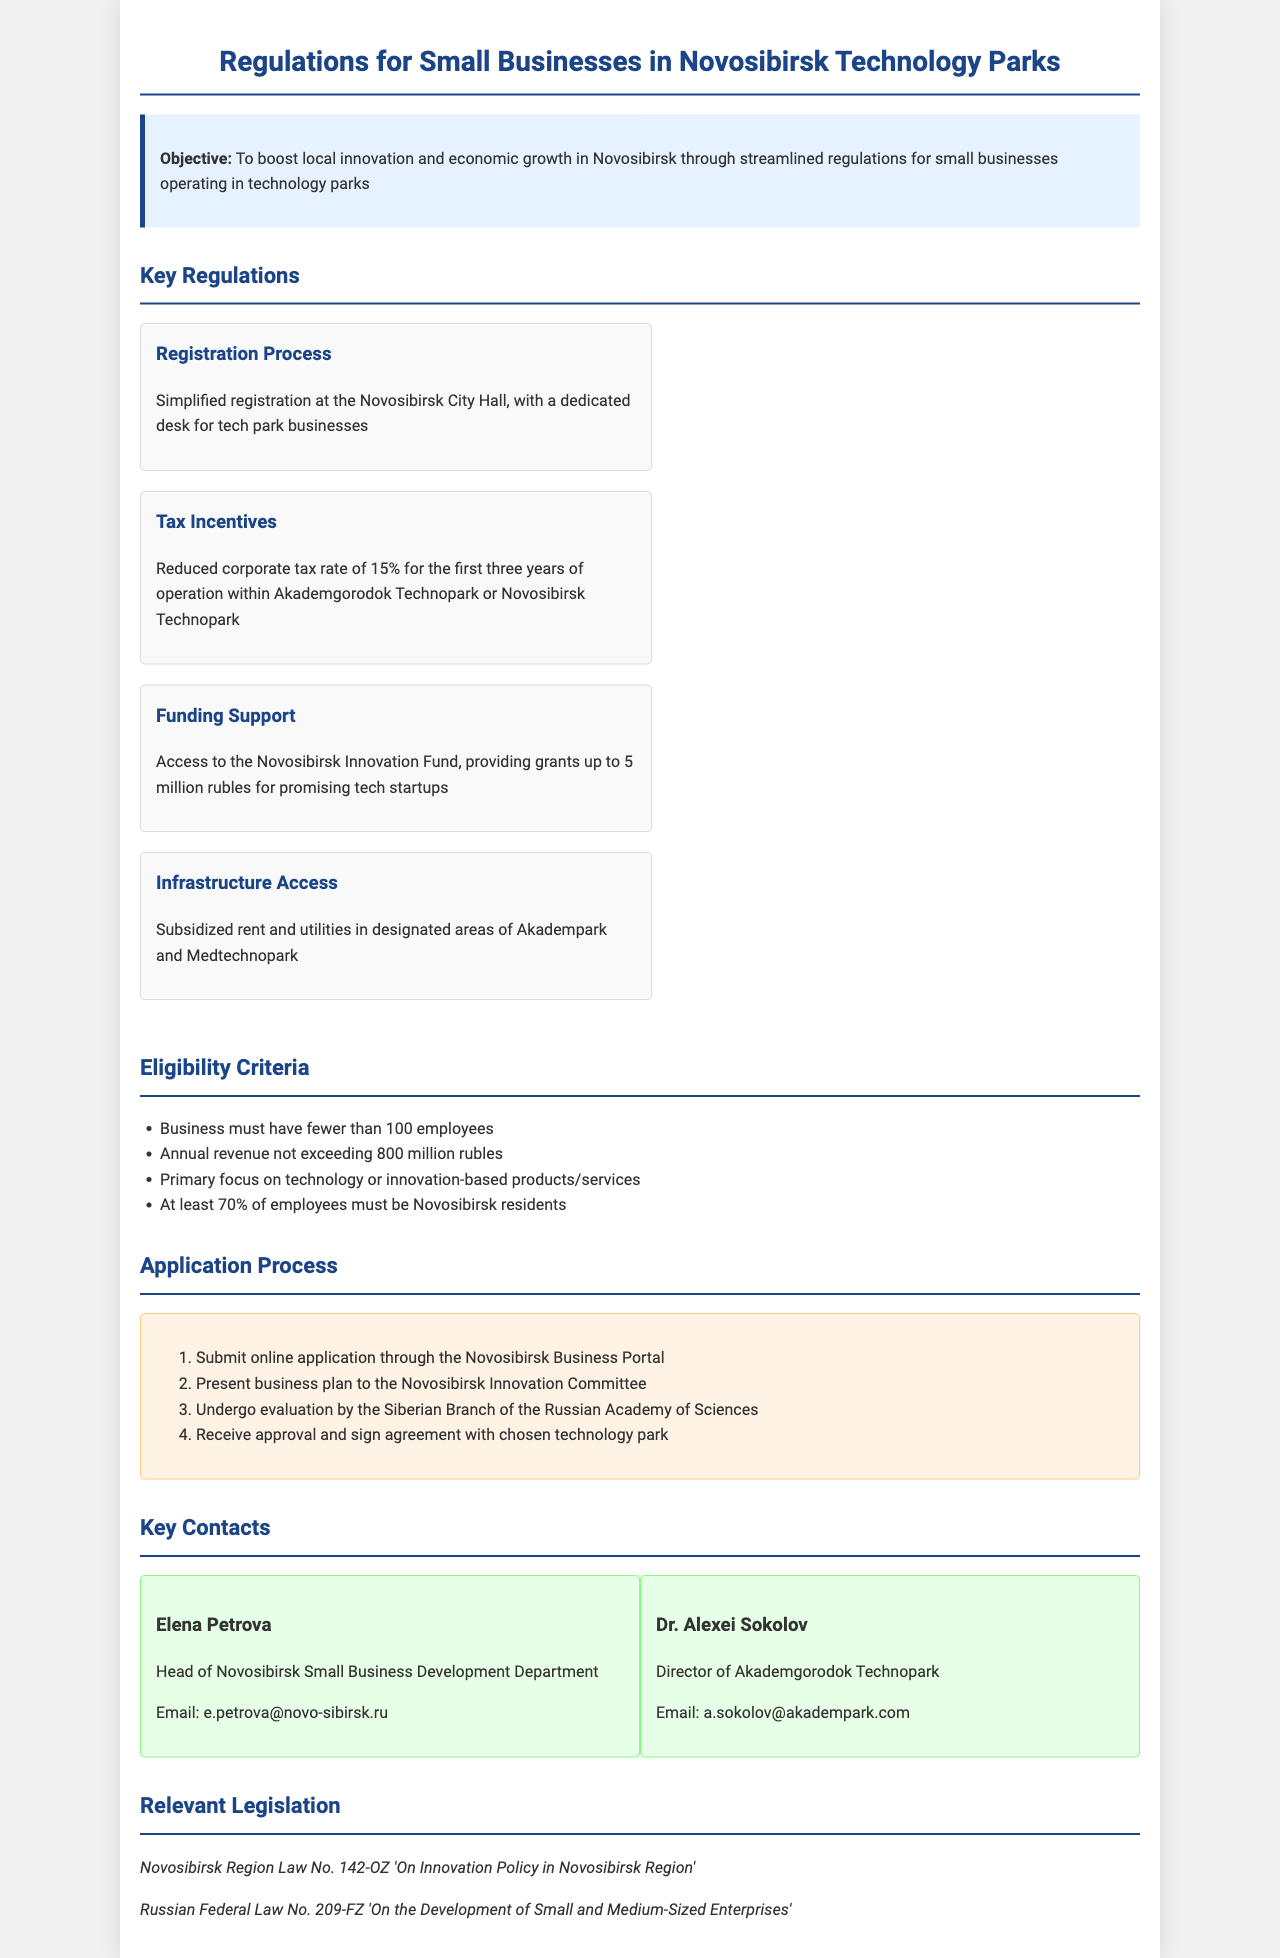What is the objective of the regulations? The objective is stated in the document, focusing on enhancing innovation and economic growth in Novosibirsk through business regulations.
Answer: To boost local innovation and economic growth What are the tax incentives for small businesses? The document specifies the tax incentives provided to eligible small businesses in technology parks, particularly the corporate tax rate.
Answer: Reduced corporate tax rate of 15% What is the maximum grant amount available from the Novosibirsk Innovation Fund? The document outlines the funding support available to startups, including the maximum grant amount offered.
Answer: 5 million rubles How many employees must a business have to be eligible? One of the eligibility criteria mentioned in the document refers to the maximum number of employees a business can have.
Answer: Fewer than 100 employees Which email belongs to the Head of Novosibirsk Small Business Development Department? The document includes contact information for key individuals, including their email addresses.
Answer: e.petrova@novo-sibirsk.ru What is the first step in the application process? The application process is detailed in the document, specifying the initial action required to apply.
Answer: Submit online application through the Novosibirsk Business Portal Which law pertains to innovation policy in Novosibirsk Region? The document lists relevant legislation, including specific laws that guide innovation policy in the region.
Answer: Novosibirsk Region Law No. 142-OZ What must employees' residency status be for a business to qualify? The document states a specific requirement regarding employee residency for eligibility in the program.
Answer: At least 70% must be Novosibirsk residents 